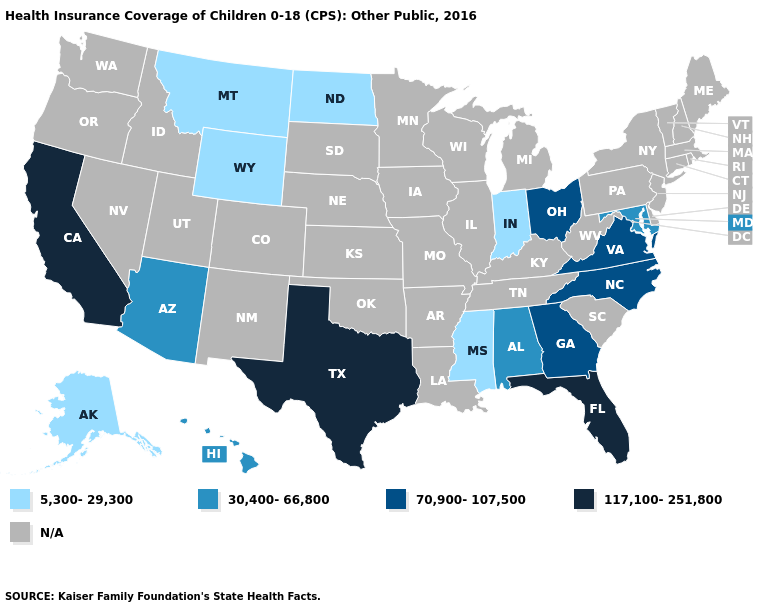What is the value of New Jersey?
Give a very brief answer. N/A. What is the value of Indiana?
Be succinct. 5,300-29,300. Name the states that have a value in the range 5,300-29,300?
Be succinct. Alaska, Indiana, Mississippi, Montana, North Dakota, Wyoming. What is the lowest value in the West?
Quick response, please. 5,300-29,300. What is the value of Kentucky?
Short answer required. N/A. What is the highest value in the MidWest ?
Answer briefly. 70,900-107,500. Name the states that have a value in the range 70,900-107,500?
Be succinct. Georgia, North Carolina, Ohio, Virginia. Does the first symbol in the legend represent the smallest category?
Quick response, please. Yes. What is the value of Rhode Island?
Answer briefly. N/A. What is the value of Wisconsin?
Write a very short answer. N/A. Is the legend a continuous bar?
Keep it brief. No. What is the highest value in states that border New Mexico?
Give a very brief answer. 117,100-251,800. Name the states that have a value in the range 70,900-107,500?
Concise answer only. Georgia, North Carolina, Ohio, Virginia. 